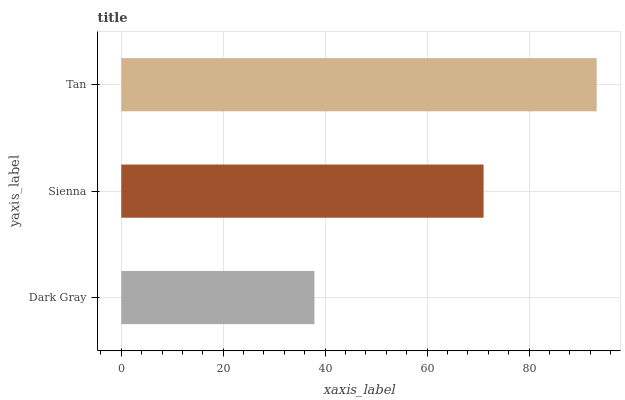Is Dark Gray the minimum?
Answer yes or no. Yes. Is Tan the maximum?
Answer yes or no. Yes. Is Sienna the minimum?
Answer yes or no. No. Is Sienna the maximum?
Answer yes or no. No. Is Sienna greater than Dark Gray?
Answer yes or no. Yes. Is Dark Gray less than Sienna?
Answer yes or no. Yes. Is Dark Gray greater than Sienna?
Answer yes or no. No. Is Sienna less than Dark Gray?
Answer yes or no. No. Is Sienna the high median?
Answer yes or no. Yes. Is Sienna the low median?
Answer yes or no. Yes. Is Tan the high median?
Answer yes or no. No. Is Tan the low median?
Answer yes or no. No. 